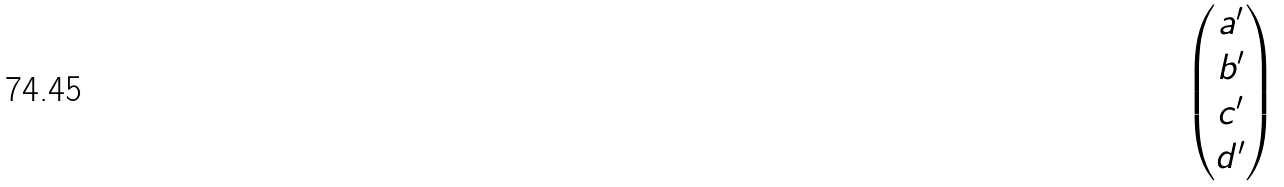<formula> <loc_0><loc_0><loc_500><loc_500>\begin{pmatrix} a ^ { \prime } \\ b ^ { \prime } \\ c ^ { \prime } \\ d ^ { \prime } \end{pmatrix}</formula> 